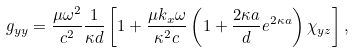<formula> <loc_0><loc_0><loc_500><loc_500>g _ { y y } = \frac { \mu \omega ^ { 2 } } { c ^ { 2 } } \frac { 1 } { \kappa d } \left [ 1 + \frac { \mu k _ { x } \omega } { \kappa ^ { 2 } c } \left ( 1 + \frac { 2 \kappa a } { d } e ^ { 2 \kappa a } \right ) \chi _ { y z } \right ] ,</formula> 